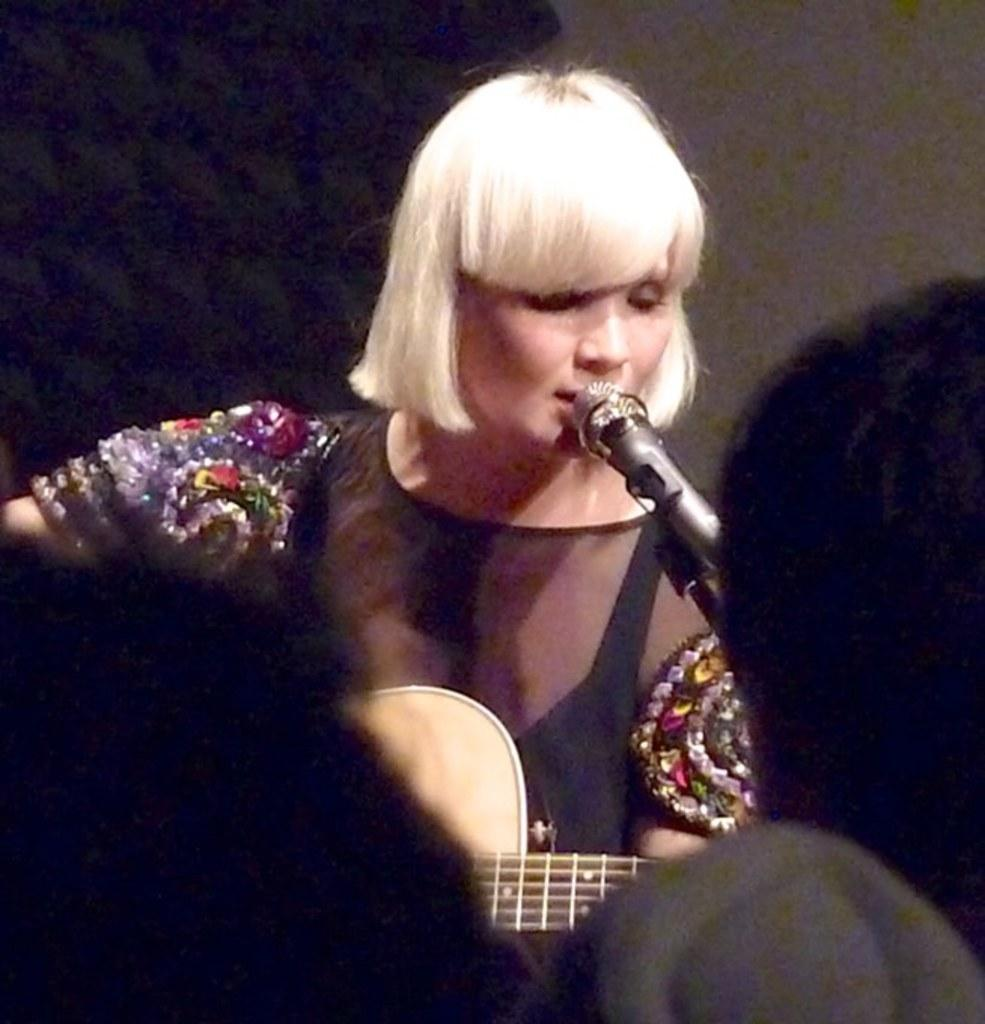Who is the main subject in the image? There is a woman in the image. What is the woman wearing? The woman is wearing a black dress. What is the woman holding in the image? The woman is holding a guitar. What is the woman doing in the image? The woman is singing a song. What is in front of the woman that might be used for amplifying her voice? There is a microphone with a stand in front of the woman. What is visible behind the woman? There is a wall behind the woman. How many kittens are playing with a comb on the wall behind the woman? There are no kittens or combs present on the wall behind the woman in the image. 